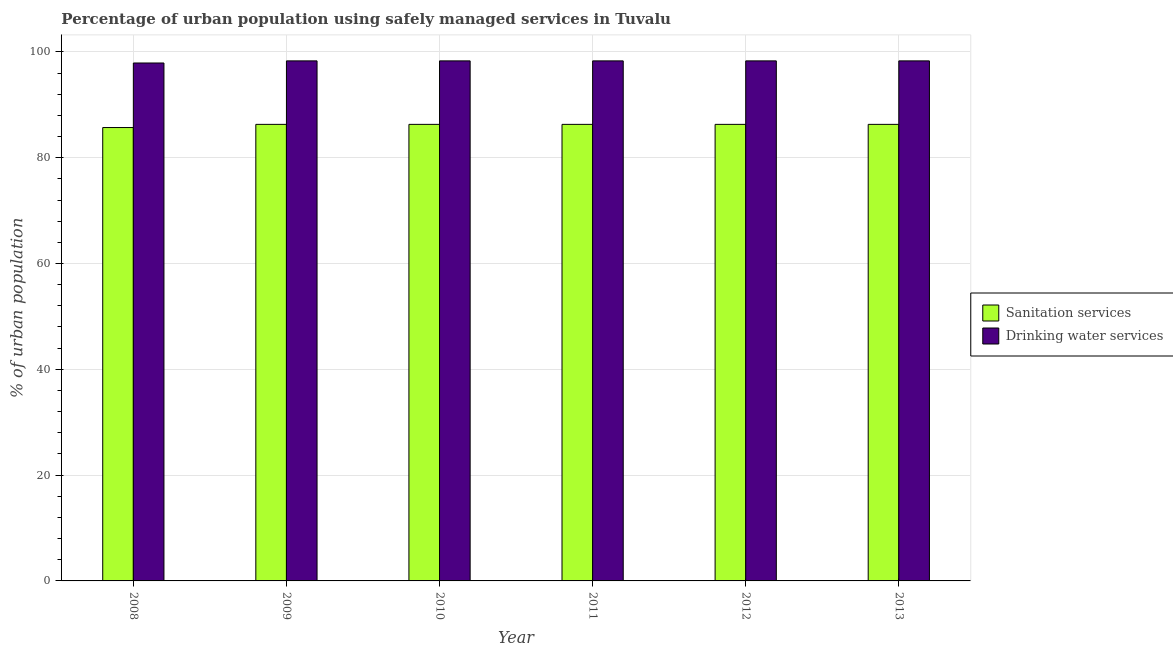Are the number of bars per tick equal to the number of legend labels?
Your answer should be very brief. Yes. Are the number of bars on each tick of the X-axis equal?
Make the answer very short. Yes. How many bars are there on the 1st tick from the left?
Give a very brief answer. 2. How many bars are there on the 4th tick from the right?
Provide a succinct answer. 2. What is the percentage of urban population who used sanitation services in 2010?
Give a very brief answer. 86.3. Across all years, what is the maximum percentage of urban population who used drinking water services?
Provide a short and direct response. 98.3. Across all years, what is the minimum percentage of urban population who used sanitation services?
Give a very brief answer. 85.7. What is the total percentage of urban population who used drinking water services in the graph?
Ensure brevity in your answer.  589.4. What is the difference between the percentage of urban population who used sanitation services in 2008 and the percentage of urban population who used drinking water services in 2009?
Offer a terse response. -0.6. What is the average percentage of urban population who used sanitation services per year?
Provide a succinct answer. 86.2. What is the ratio of the percentage of urban population who used sanitation services in 2008 to that in 2013?
Give a very brief answer. 0.99. Is the percentage of urban population who used sanitation services in 2008 less than that in 2012?
Offer a terse response. Yes. Is the difference between the percentage of urban population who used drinking water services in 2009 and 2013 greater than the difference between the percentage of urban population who used sanitation services in 2009 and 2013?
Provide a short and direct response. No. What is the difference between the highest and the second highest percentage of urban population who used sanitation services?
Ensure brevity in your answer.  0. What is the difference between the highest and the lowest percentage of urban population who used drinking water services?
Keep it short and to the point. 0.4. In how many years, is the percentage of urban population who used drinking water services greater than the average percentage of urban population who used drinking water services taken over all years?
Make the answer very short. 5. Is the sum of the percentage of urban population who used sanitation services in 2011 and 2012 greater than the maximum percentage of urban population who used drinking water services across all years?
Offer a terse response. Yes. What does the 2nd bar from the left in 2010 represents?
Give a very brief answer. Drinking water services. What does the 1st bar from the right in 2008 represents?
Provide a succinct answer. Drinking water services. How many bars are there?
Ensure brevity in your answer.  12. Are all the bars in the graph horizontal?
Make the answer very short. No. How many years are there in the graph?
Give a very brief answer. 6. What is the difference between two consecutive major ticks on the Y-axis?
Ensure brevity in your answer.  20. Are the values on the major ticks of Y-axis written in scientific E-notation?
Provide a succinct answer. No. Does the graph contain any zero values?
Keep it short and to the point. No. Where does the legend appear in the graph?
Your answer should be very brief. Center right. What is the title of the graph?
Provide a short and direct response. Percentage of urban population using safely managed services in Tuvalu. What is the label or title of the Y-axis?
Provide a succinct answer. % of urban population. What is the % of urban population in Sanitation services in 2008?
Provide a short and direct response. 85.7. What is the % of urban population in Drinking water services in 2008?
Your answer should be compact. 97.9. What is the % of urban population in Sanitation services in 2009?
Your answer should be compact. 86.3. What is the % of urban population of Drinking water services in 2009?
Provide a short and direct response. 98.3. What is the % of urban population in Sanitation services in 2010?
Provide a succinct answer. 86.3. What is the % of urban population in Drinking water services in 2010?
Provide a succinct answer. 98.3. What is the % of urban population in Sanitation services in 2011?
Offer a very short reply. 86.3. What is the % of urban population of Drinking water services in 2011?
Ensure brevity in your answer.  98.3. What is the % of urban population of Sanitation services in 2012?
Offer a very short reply. 86.3. What is the % of urban population of Drinking water services in 2012?
Make the answer very short. 98.3. What is the % of urban population of Sanitation services in 2013?
Provide a succinct answer. 86.3. What is the % of urban population of Drinking water services in 2013?
Provide a short and direct response. 98.3. Across all years, what is the maximum % of urban population of Sanitation services?
Give a very brief answer. 86.3. Across all years, what is the maximum % of urban population in Drinking water services?
Your answer should be very brief. 98.3. Across all years, what is the minimum % of urban population of Sanitation services?
Provide a succinct answer. 85.7. Across all years, what is the minimum % of urban population of Drinking water services?
Your answer should be compact. 97.9. What is the total % of urban population in Sanitation services in the graph?
Make the answer very short. 517.2. What is the total % of urban population in Drinking water services in the graph?
Your answer should be compact. 589.4. What is the difference between the % of urban population in Sanitation services in 2008 and that in 2009?
Ensure brevity in your answer.  -0.6. What is the difference between the % of urban population in Drinking water services in 2008 and that in 2009?
Make the answer very short. -0.4. What is the difference between the % of urban population of Sanitation services in 2008 and that in 2010?
Your answer should be very brief. -0.6. What is the difference between the % of urban population of Drinking water services in 2008 and that in 2010?
Provide a succinct answer. -0.4. What is the difference between the % of urban population of Drinking water services in 2008 and that in 2011?
Provide a succinct answer. -0.4. What is the difference between the % of urban population in Sanitation services in 2008 and that in 2012?
Your answer should be very brief. -0.6. What is the difference between the % of urban population in Drinking water services in 2008 and that in 2012?
Keep it short and to the point. -0.4. What is the difference between the % of urban population in Drinking water services in 2009 and that in 2010?
Provide a short and direct response. 0. What is the difference between the % of urban population of Sanitation services in 2009 and that in 2011?
Make the answer very short. 0. What is the difference between the % of urban population in Drinking water services in 2009 and that in 2011?
Make the answer very short. 0. What is the difference between the % of urban population of Sanitation services in 2009 and that in 2012?
Provide a short and direct response. 0. What is the difference between the % of urban population in Drinking water services in 2009 and that in 2012?
Make the answer very short. 0. What is the difference between the % of urban population of Drinking water services in 2010 and that in 2011?
Your answer should be very brief. 0. What is the difference between the % of urban population in Drinking water services in 2010 and that in 2012?
Your response must be concise. 0. What is the difference between the % of urban population in Sanitation services in 2010 and that in 2013?
Your response must be concise. 0. What is the difference between the % of urban population in Sanitation services in 2011 and that in 2012?
Offer a terse response. 0. What is the difference between the % of urban population of Sanitation services in 2011 and that in 2013?
Keep it short and to the point. 0. What is the difference between the % of urban population of Drinking water services in 2011 and that in 2013?
Give a very brief answer. 0. What is the difference between the % of urban population of Sanitation services in 2012 and that in 2013?
Provide a succinct answer. 0. What is the difference between the % of urban population of Sanitation services in 2008 and the % of urban population of Drinking water services in 2011?
Give a very brief answer. -12.6. What is the difference between the % of urban population of Sanitation services in 2008 and the % of urban population of Drinking water services in 2013?
Offer a terse response. -12.6. What is the difference between the % of urban population of Sanitation services in 2009 and the % of urban population of Drinking water services in 2011?
Provide a succinct answer. -12. What is the difference between the % of urban population in Sanitation services in 2009 and the % of urban population in Drinking water services in 2012?
Your answer should be compact. -12. What is the difference between the % of urban population in Sanitation services in 2010 and the % of urban population in Drinking water services in 2012?
Offer a very short reply. -12. What is the difference between the % of urban population in Sanitation services in 2011 and the % of urban population in Drinking water services in 2012?
Your answer should be compact. -12. What is the difference between the % of urban population in Sanitation services in 2011 and the % of urban population in Drinking water services in 2013?
Give a very brief answer. -12. What is the average % of urban population in Sanitation services per year?
Keep it short and to the point. 86.2. What is the average % of urban population in Drinking water services per year?
Make the answer very short. 98.23. What is the ratio of the % of urban population in Sanitation services in 2008 to that in 2010?
Provide a succinct answer. 0.99. What is the ratio of the % of urban population in Drinking water services in 2008 to that in 2010?
Make the answer very short. 1. What is the ratio of the % of urban population in Sanitation services in 2008 to that in 2012?
Your answer should be very brief. 0.99. What is the ratio of the % of urban population of Sanitation services in 2008 to that in 2013?
Your answer should be very brief. 0.99. What is the ratio of the % of urban population in Sanitation services in 2009 to that in 2010?
Provide a succinct answer. 1. What is the ratio of the % of urban population of Drinking water services in 2009 to that in 2012?
Your answer should be very brief. 1. What is the ratio of the % of urban population in Sanitation services in 2010 to that in 2012?
Offer a terse response. 1. What is the ratio of the % of urban population in Drinking water services in 2010 to that in 2012?
Your response must be concise. 1. What is the ratio of the % of urban population in Sanitation services in 2010 to that in 2013?
Give a very brief answer. 1. What is the ratio of the % of urban population of Drinking water services in 2010 to that in 2013?
Your answer should be very brief. 1. What is the ratio of the % of urban population in Sanitation services in 2011 to that in 2012?
Make the answer very short. 1. What is the ratio of the % of urban population in Drinking water services in 2011 to that in 2012?
Offer a terse response. 1. What is the ratio of the % of urban population of Drinking water services in 2011 to that in 2013?
Keep it short and to the point. 1. What is the ratio of the % of urban population of Sanitation services in 2012 to that in 2013?
Ensure brevity in your answer.  1. What is the ratio of the % of urban population in Drinking water services in 2012 to that in 2013?
Offer a terse response. 1. What is the difference between the highest and the second highest % of urban population of Sanitation services?
Offer a terse response. 0. What is the difference between the highest and the lowest % of urban population in Sanitation services?
Your answer should be compact. 0.6. 